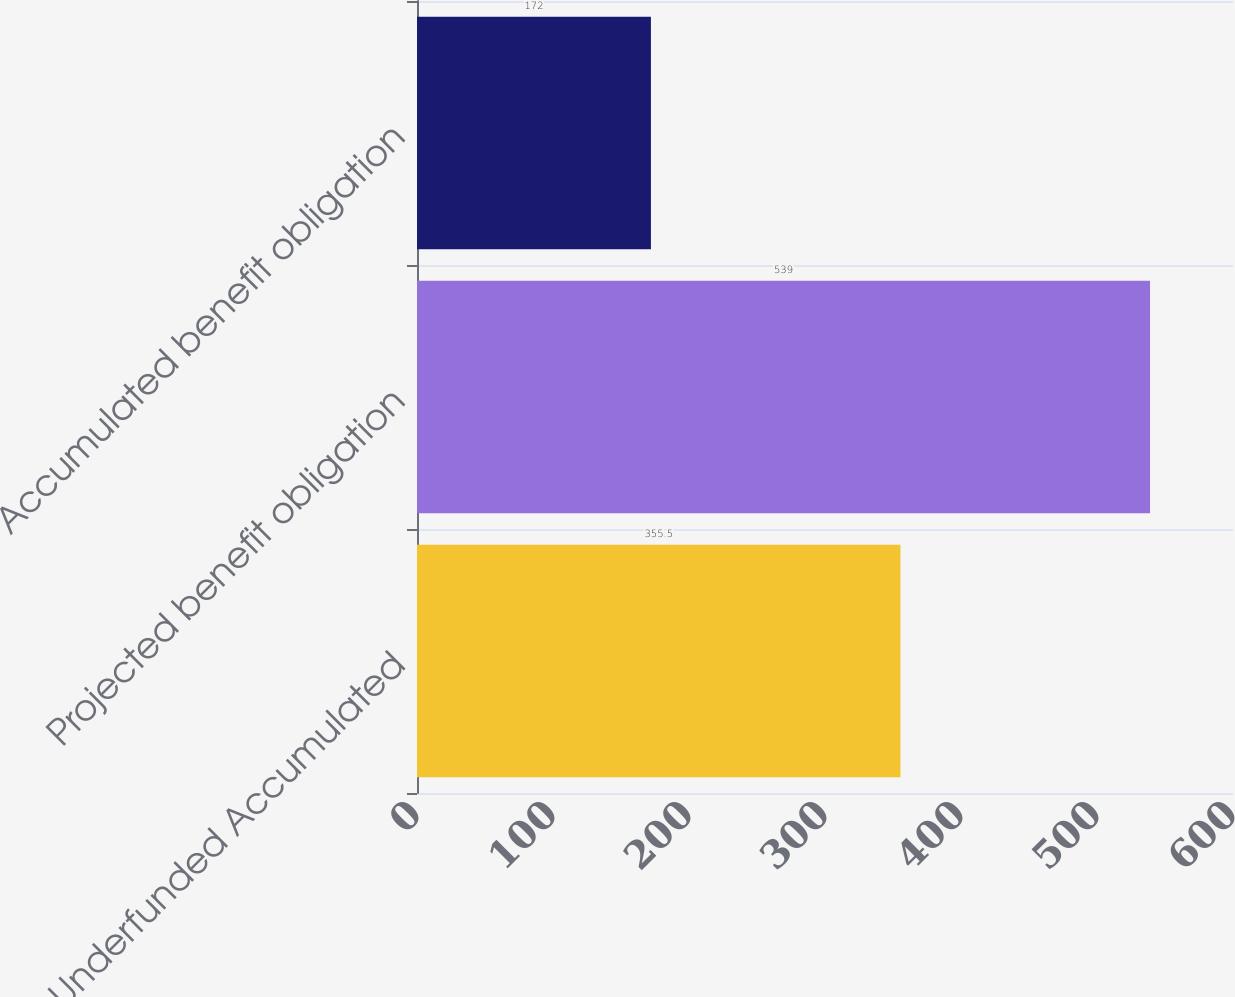Convert chart. <chart><loc_0><loc_0><loc_500><loc_500><bar_chart><fcel>Underfunded Accumulated<fcel>Projected benefit obligation<fcel>Accumulated benefit obligation<nl><fcel>355.5<fcel>539<fcel>172<nl></chart> 